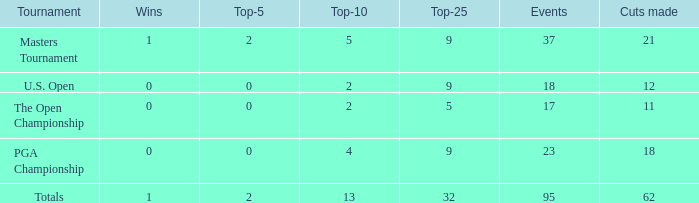What are the smallest top 5 winners with negative values? None. 